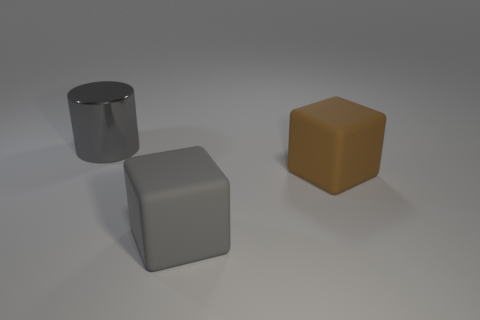Add 1 large things. How many objects exist? 4 Subtract all cylinders. How many objects are left? 2 Add 3 cubes. How many cubes are left? 5 Add 1 large metallic cylinders. How many large metallic cylinders exist? 2 Subtract 0 yellow blocks. How many objects are left? 3 Subtract all large metal cylinders. Subtract all matte blocks. How many objects are left? 0 